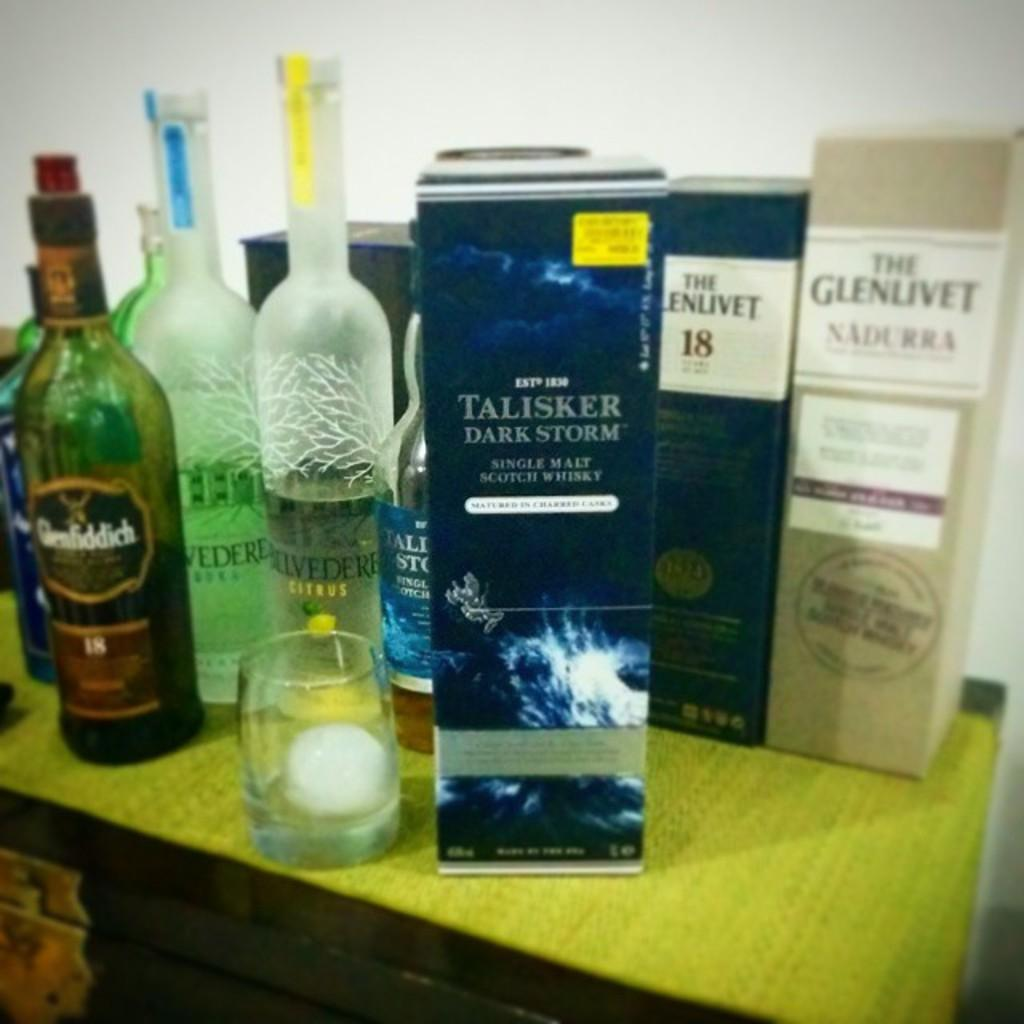Provide a one-sentence caption for the provided image. A box marked Talisker Dark Storm single malt scotch whisky is on a table amongst other liquor. 